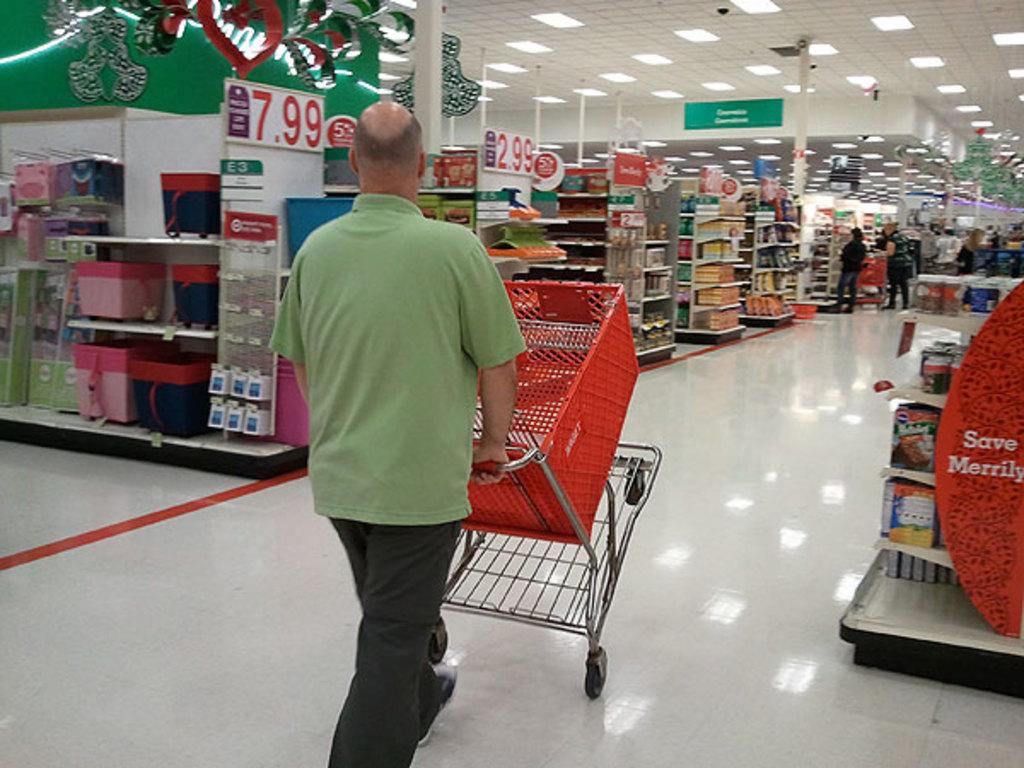How does it want me to save according to the sign on the right?
Your answer should be compact. Merrily. What price is the closest price?
Ensure brevity in your answer.  7.99. 